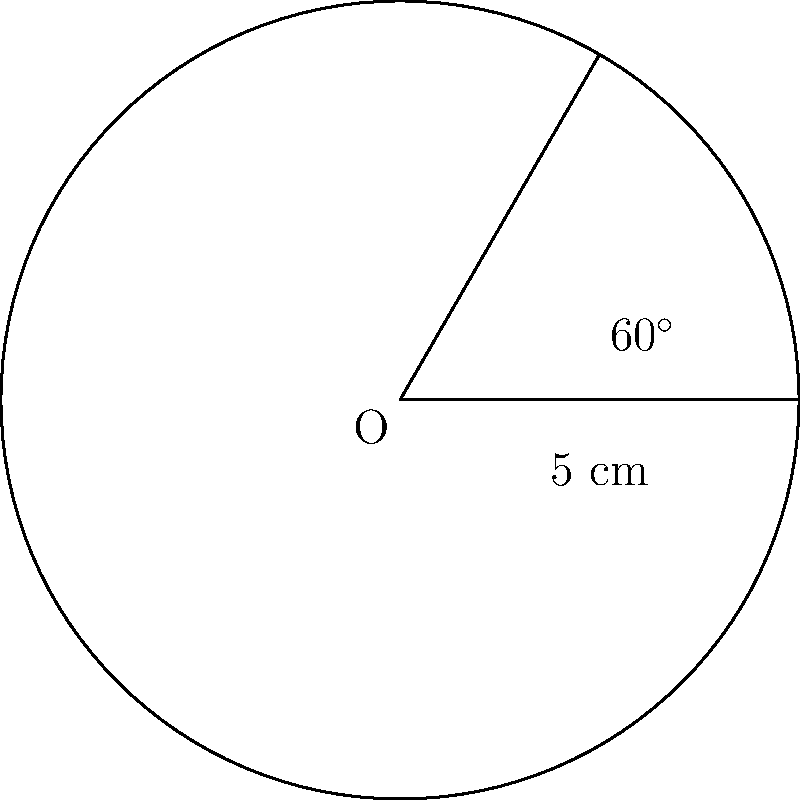In a circular pizza with a radius of 5 cm, you've cut out a slice that forms a 60° angle at the center. What is the area of this pizza slice in square centimeters? Round your answer to two decimal places. To find the area of the pizza slice (sector), we'll follow these steps:

1) The formula for the area of a sector is:
   $$A = \frac{\theta}{360^\circ} \pi r^2$$
   where $\theta$ is the central angle in degrees, and $r$ is the radius.

2) We're given:
   $\theta = 60^\circ$
   $r = 5$ cm

3) Let's substitute these values into the formula:
   $$A = \frac{60^\circ}{360^\circ} \pi (5\text{ cm})^2$$

4) Simplify:
   $$A = \frac{1}{6} \pi (25\text{ cm}^2)$$

5) Calculate:
   $$A = \frac{25\pi}{6} \text{ cm}^2 \approx 13.0899\text{ cm}^2$$

6) Rounding to two decimal places:
   $$A \approx 13.09\text{ cm}^2$$

This represents the area of the pizza slice.
Answer: 13.09 cm² 